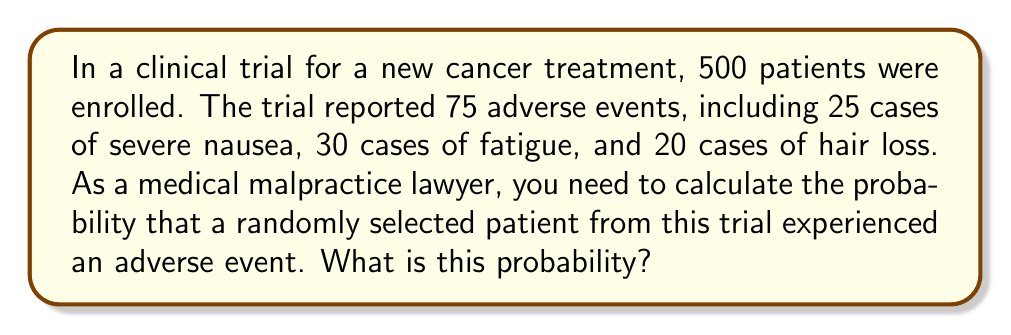Provide a solution to this math problem. To calculate the probability of a randomly selected patient experiencing an adverse event, we need to use the following steps:

1. Identify the total number of patients in the trial:
   $N = 500$

2. Count the total number of adverse events:
   $\text{Adverse events} = 25 + 30 + 20 = 75$

3. Calculate the probability using the formula:
   $$P(\text{adverse event}) = \frac{\text{Number of adverse events}}{\text{Total number of patients}}$$

4. Substitute the values:
   $$P(\text{adverse event}) = \frac{75}{500}$$

5. Simplify the fraction:
   $$P(\text{adverse event}) = \frac{3}{20} = 0.15$$

6. Convert to a percentage (optional):
   $0.15 \times 100\% = 15\%$

Therefore, the probability that a randomly selected patient from this clinical trial experienced an adverse event is 0.15 or 15%.
Answer: 0.15 